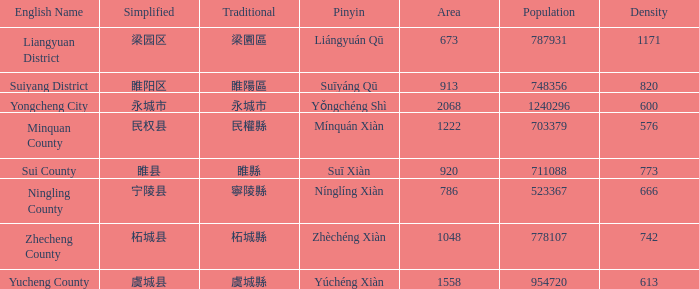What is the traditional with density of 820? 睢陽區. 